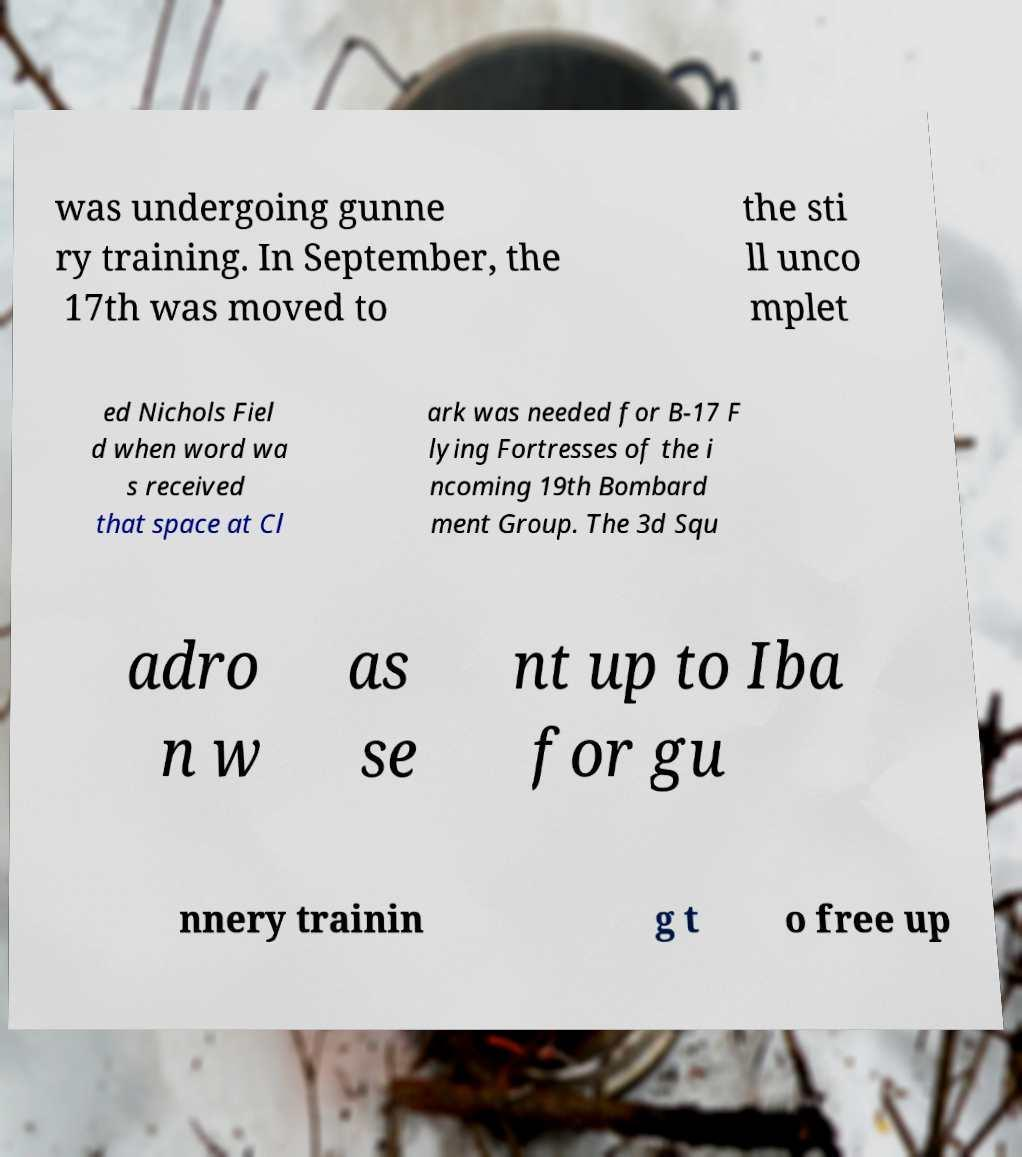For documentation purposes, I need the text within this image transcribed. Could you provide that? was undergoing gunne ry training. In September, the 17th was moved to the sti ll unco mplet ed Nichols Fiel d when word wa s received that space at Cl ark was needed for B-17 F lying Fortresses of the i ncoming 19th Bombard ment Group. The 3d Squ adro n w as se nt up to Iba for gu nnery trainin g t o free up 